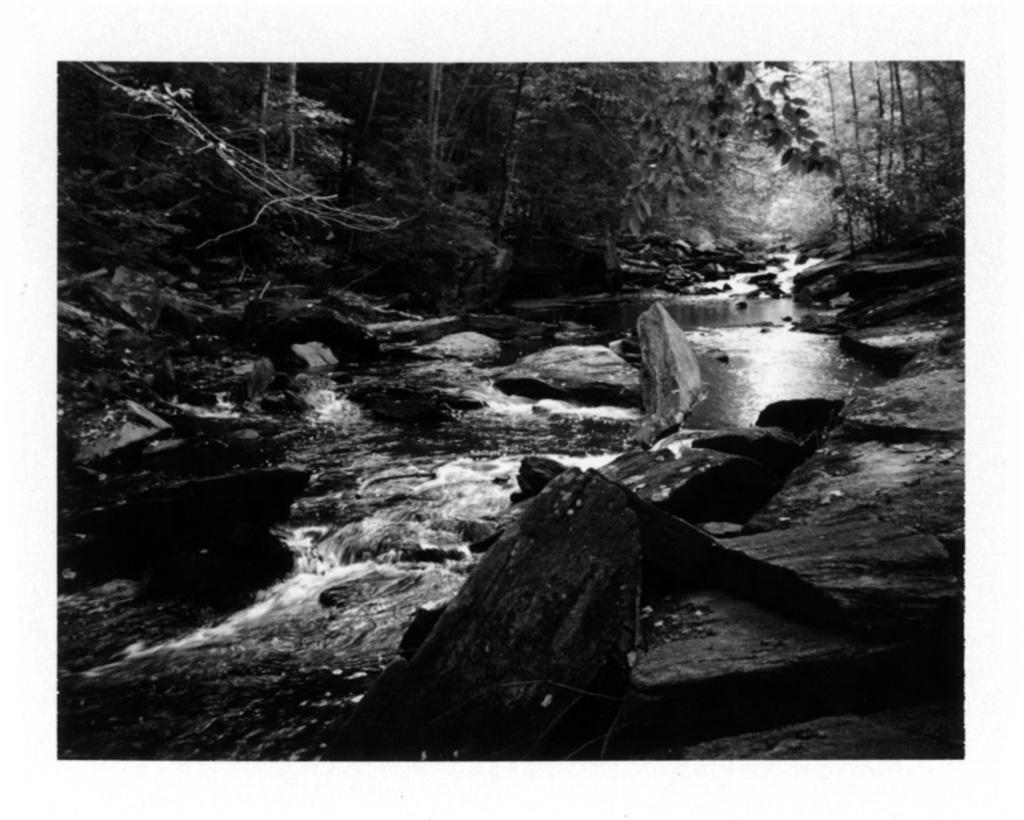Describe this image in one or two sentences. This is a black and white image. In the center of the image there is water. In the background of the image there are trees. At the bottom of the image there are rocks. 